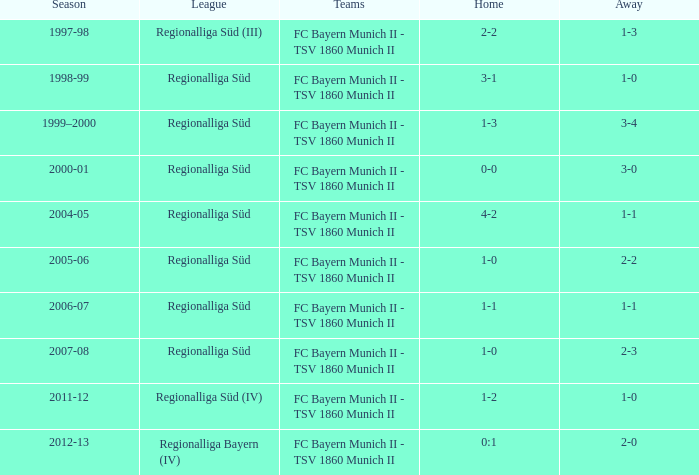What is the home with a 1-1 away in the 2004-05 season? 4-2. 